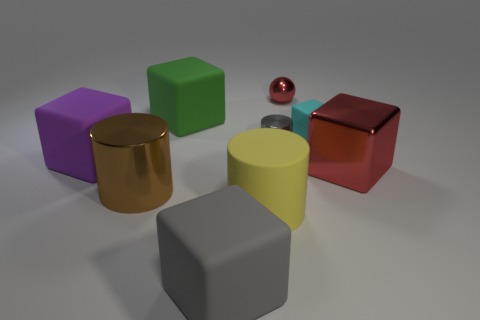What number of cyan rubber objects are the same shape as the yellow object?
Offer a terse response. 0. What material is the yellow thing?
Offer a very short reply. Rubber. Does the brown object have the same shape as the small rubber thing?
Offer a terse response. No. Are there any large purple blocks made of the same material as the cyan thing?
Ensure brevity in your answer.  Yes. The big rubber block that is both on the right side of the large purple rubber block and behind the big gray matte cube is what color?
Offer a terse response. Green. There is a big cube behind the gray cylinder; what is its material?
Keep it short and to the point. Rubber. Are there any yellow things that have the same shape as the gray rubber object?
Provide a succinct answer. No. What number of other objects are there of the same shape as the tiny gray thing?
Make the answer very short. 2. Do the green object and the big shiny thing that is on the right side of the large yellow rubber cylinder have the same shape?
Your answer should be very brief. Yes. There is another large thing that is the same shape as the brown object; what is its material?
Your answer should be compact. Rubber. 